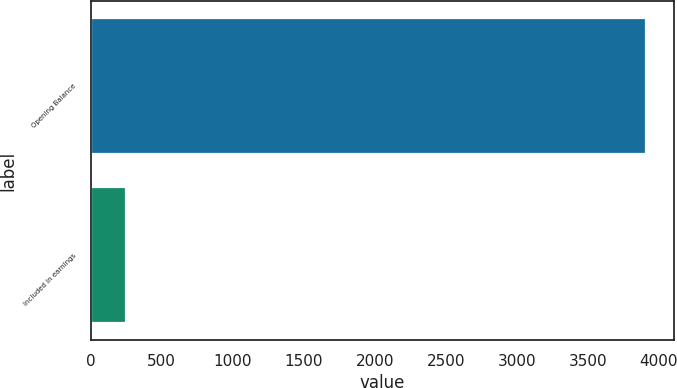<chart> <loc_0><loc_0><loc_500><loc_500><bar_chart><fcel>Opening Balance<fcel>Included in earnings<nl><fcel>3910<fcel>250<nl></chart> 